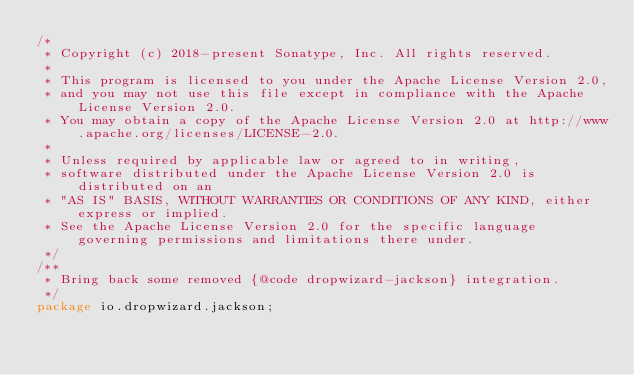<code> <loc_0><loc_0><loc_500><loc_500><_Java_>/*
 * Copyright (c) 2018-present Sonatype, Inc. All rights reserved.
 *
 * This program is licensed to you under the Apache License Version 2.0,
 * and you may not use this file except in compliance with the Apache License Version 2.0.
 * You may obtain a copy of the Apache License Version 2.0 at http://www.apache.org/licenses/LICENSE-2.0.
 *
 * Unless required by applicable law or agreed to in writing,
 * software distributed under the Apache License Version 2.0 is distributed on an
 * "AS IS" BASIS, WITHOUT WARRANTIES OR CONDITIONS OF ANY KIND, either express or implied.
 * See the Apache License Version 2.0 for the specific language governing permissions and limitations there under.
 */
/**
 * Bring back some removed {@code dropwizard-jackson} integration.
 */
package io.dropwizard.jackson;</code> 